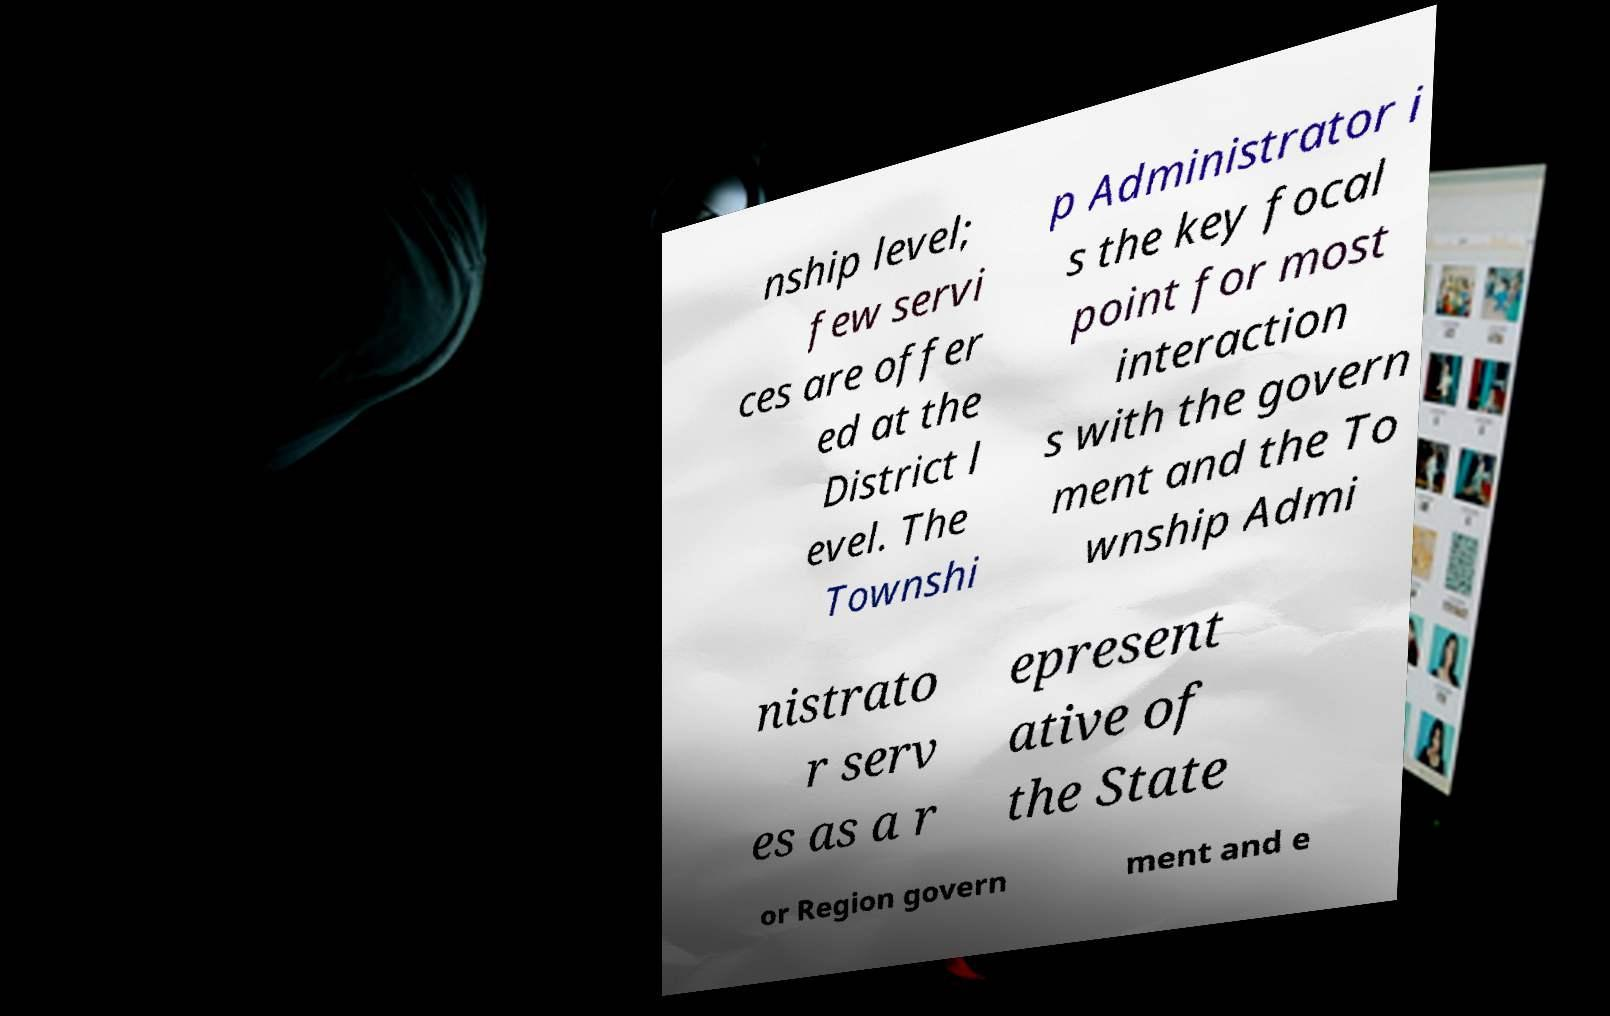Could you assist in decoding the text presented in this image and type it out clearly? nship level; few servi ces are offer ed at the District l evel. The Townshi p Administrator i s the key focal point for most interaction s with the govern ment and the To wnship Admi nistrato r serv es as a r epresent ative of the State or Region govern ment and e 